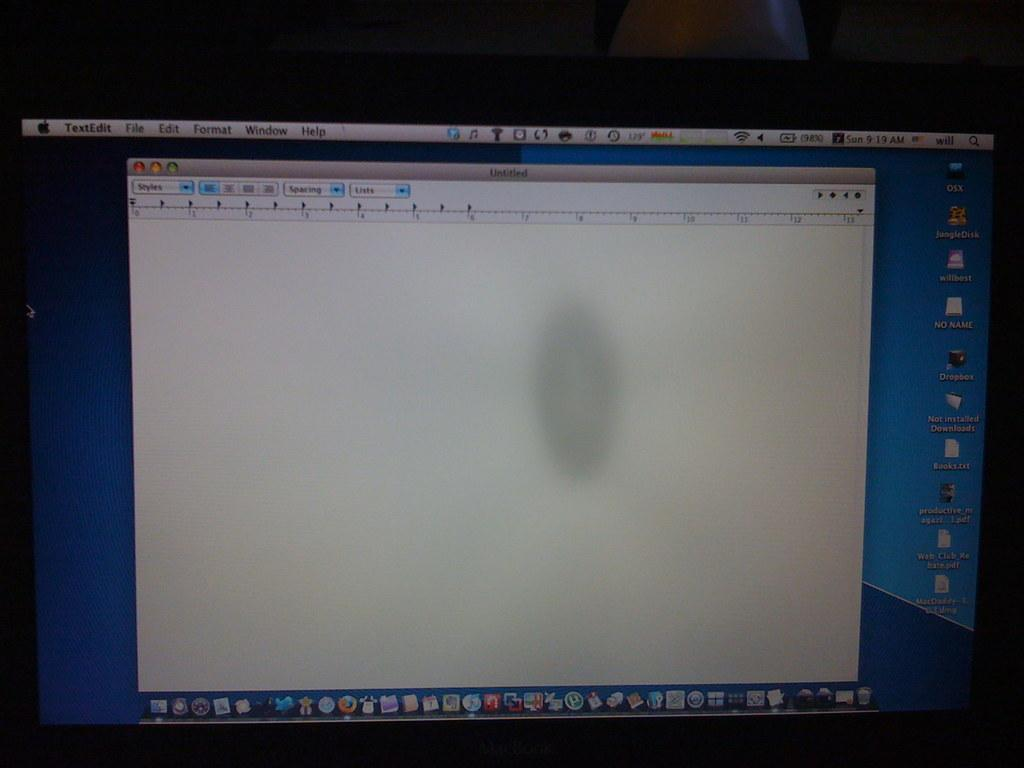Provide a one-sentence caption for the provided image. A blank TextEdit page is open at 9:19 am. 